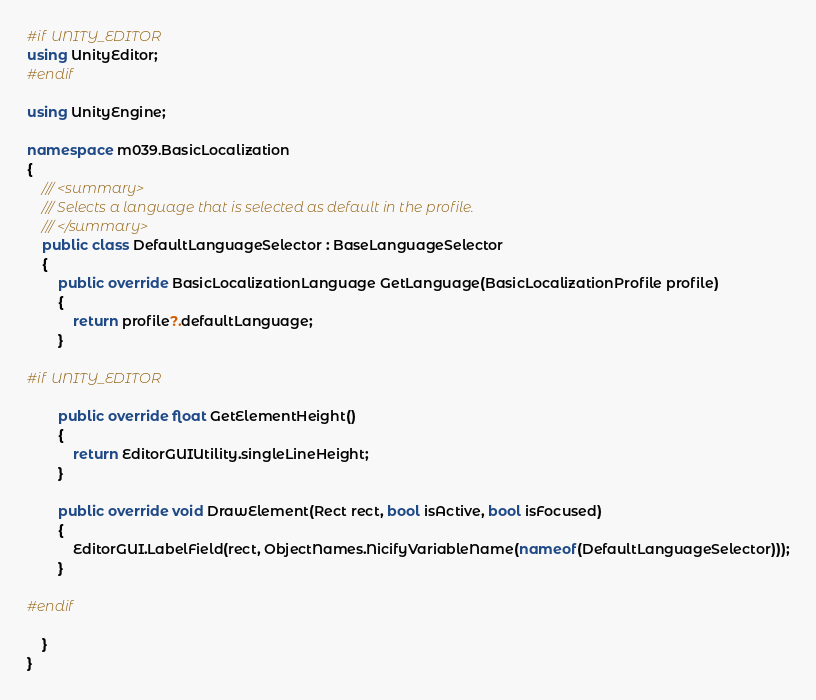Convert code to text. <code><loc_0><loc_0><loc_500><loc_500><_C#_>#if UNITY_EDITOR
using UnityEditor;
#endif

using UnityEngine;

namespace m039.BasicLocalization
{
    /// <summary>
    /// Selects a language that is selected as default in the profile.
    /// </summary>
    public class DefaultLanguageSelector : BaseLanguageSelector
    {
        public override BasicLocalizationLanguage GetLanguage(BasicLocalizationProfile profile)
        {
            return profile?.defaultLanguage;
        }

#if UNITY_EDITOR

        public override float GetElementHeight()
        {
            return EditorGUIUtility.singleLineHeight;
        }

        public override void DrawElement(Rect rect, bool isActive, bool isFocused)
        {
            EditorGUI.LabelField(rect, ObjectNames.NicifyVariableName(nameof(DefaultLanguageSelector)));
        }

#endif

    }
}
</code> 